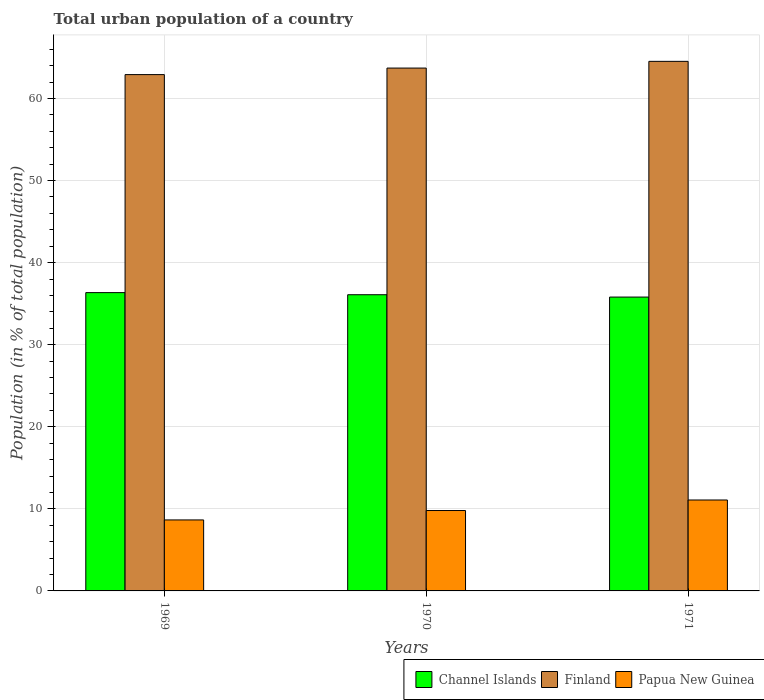What is the label of the 2nd group of bars from the left?
Provide a short and direct response. 1970. In how many cases, is the number of bars for a given year not equal to the number of legend labels?
Keep it short and to the point. 0. What is the urban population in Papua New Guinea in 1971?
Keep it short and to the point. 11.08. Across all years, what is the maximum urban population in Finland?
Keep it short and to the point. 64.52. Across all years, what is the minimum urban population in Finland?
Your answer should be very brief. 62.91. What is the total urban population in Channel Islands in the graph?
Provide a short and direct response. 108.24. What is the difference between the urban population in Channel Islands in 1970 and that in 1971?
Ensure brevity in your answer.  0.28. What is the difference between the urban population in Finland in 1969 and the urban population in Channel Islands in 1970?
Provide a succinct answer. 26.82. What is the average urban population in Finland per year?
Offer a very short reply. 63.71. In the year 1969, what is the difference between the urban population in Finland and urban population in Papua New Guinea?
Provide a short and direct response. 54.26. In how many years, is the urban population in Finland greater than 6 %?
Your response must be concise. 3. What is the ratio of the urban population in Papua New Guinea in 1970 to that in 1971?
Your answer should be very brief. 0.88. What is the difference between the highest and the second highest urban population in Papua New Guinea?
Your answer should be very brief. 1.28. What is the difference between the highest and the lowest urban population in Finland?
Ensure brevity in your answer.  1.61. In how many years, is the urban population in Papua New Guinea greater than the average urban population in Papua New Guinea taken over all years?
Your answer should be very brief. 1. What does the 2nd bar from the left in 1971 represents?
Keep it short and to the point. Finland. Is it the case that in every year, the sum of the urban population in Finland and urban population in Papua New Guinea is greater than the urban population in Channel Islands?
Your answer should be very brief. Yes. How many bars are there?
Your answer should be compact. 9. Are the values on the major ticks of Y-axis written in scientific E-notation?
Make the answer very short. No. Does the graph contain any zero values?
Ensure brevity in your answer.  No. Where does the legend appear in the graph?
Your response must be concise. Bottom right. How many legend labels are there?
Provide a short and direct response. 3. What is the title of the graph?
Offer a very short reply. Total urban population of a country. What is the label or title of the X-axis?
Offer a terse response. Years. What is the label or title of the Y-axis?
Offer a terse response. Population (in % of total population). What is the Population (in % of total population) in Channel Islands in 1969?
Keep it short and to the point. 36.35. What is the Population (in % of total population) in Finland in 1969?
Provide a succinct answer. 62.91. What is the Population (in % of total population) of Papua New Guinea in 1969?
Offer a terse response. 8.65. What is the Population (in % of total population) in Channel Islands in 1970?
Give a very brief answer. 36.09. What is the Population (in % of total population) in Finland in 1970?
Provide a succinct answer. 63.7. What is the Population (in % of total population) of Papua New Guinea in 1970?
Your answer should be very brief. 9.8. What is the Population (in % of total population) of Channel Islands in 1971?
Keep it short and to the point. 35.8. What is the Population (in % of total population) of Finland in 1971?
Offer a very short reply. 64.52. What is the Population (in % of total population) in Papua New Guinea in 1971?
Give a very brief answer. 11.08. Across all years, what is the maximum Population (in % of total population) in Channel Islands?
Ensure brevity in your answer.  36.35. Across all years, what is the maximum Population (in % of total population) in Finland?
Your answer should be very brief. 64.52. Across all years, what is the maximum Population (in % of total population) of Papua New Guinea?
Keep it short and to the point. 11.08. Across all years, what is the minimum Population (in % of total population) in Channel Islands?
Your answer should be very brief. 35.8. Across all years, what is the minimum Population (in % of total population) in Finland?
Your response must be concise. 62.91. Across all years, what is the minimum Population (in % of total population) of Papua New Guinea?
Your answer should be compact. 8.65. What is the total Population (in % of total population) in Channel Islands in the graph?
Provide a short and direct response. 108.24. What is the total Population (in % of total population) of Finland in the graph?
Make the answer very short. 191.13. What is the total Population (in % of total population) of Papua New Guinea in the graph?
Make the answer very short. 29.52. What is the difference between the Population (in % of total population) in Channel Islands in 1969 and that in 1970?
Keep it short and to the point. 0.26. What is the difference between the Population (in % of total population) of Finland in 1969 and that in 1970?
Your response must be concise. -0.8. What is the difference between the Population (in % of total population) of Papua New Guinea in 1969 and that in 1970?
Keep it short and to the point. -1.15. What is the difference between the Population (in % of total population) in Channel Islands in 1969 and that in 1971?
Provide a short and direct response. 0.54. What is the difference between the Population (in % of total population) of Finland in 1969 and that in 1971?
Your response must be concise. -1.61. What is the difference between the Population (in % of total population) in Papua New Guinea in 1969 and that in 1971?
Give a very brief answer. -2.43. What is the difference between the Population (in % of total population) of Channel Islands in 1970 and that in 1971?
Keep it short and to the point. 0.28. What is the difference between the Population (in % of total population) of Finland in 1970 and that in 1971?
Your answer should be very brief. -0.82. What is the difference between the Population (in % of total population) of Papua New Guinea in 1970 and that in 1971?
Offer a very short reply. -1.28. What is the difference between the Population (in % of total population) of Channel Islands in 1969 and the Population (in % of total population) of Finland in 1970?
Make the answer very short. -27.36. What is the difference between the Population (in % of total population) in Channel Islands in 1969 and the Population (in % of total population) in Papua New Guinea in 1970?
Your response must be concise. 26.55. What is the difference between the Population (in % of total population) of Finland in 1969 and the Population (in % of total population) of Papua New Guinea in 1970?
Your response must be concise. 53.11. What is the difference between the Population (in % of total population) of Channel Islands in 1969 and the Population (in % of total population) of Finland in 1971?
Your response must be concise. -28.18. What is the difference between the Population (in % of total population) of Channel Islands in 1969 and the Population (in % of total population) of Papua New Guinea in 1971?
Your response must be concise. 25.27. What is the difference between the Population (in % of total population) in Finland in 1969 and the Population (in % of total population) in Papua New Guinea in 1971?
Your answer should be compact. 51.83. What is the difference between the Population (in % of total population) of Channel Islands in 1970 and the Population (in % of total population) of Finland in 1971?
Your response must be concise. -28.43. What is the difference between the Population (in % of total population) of Channel Islands in 1970 and the Population (in % of total population) of Papua New Guinea in 1971?
Your answer should be very brief. 25.01. What is the difference between the Population (in % of total population) in Finland in 1970 and the Population (in % of total population) in Papua New Guinea in 1971?
Ensure brevity in your answer.  52.63. What is the average Population (in % of total population) of Channel Islands per year?
Give a very brief answer. 36.08. What is the average Population (in % of total population) of Finland per year?
Keep it short and to the point. 63.71. What is the average Population (in % of total population) of Papua New Guinea per year?
Your answer should be compact. 9.84. In the year 1969, what is the difference between the Population (in % of total population) in Channel Islands and Population (in % of total population) in Finland?
Your answer should be compact. -26.56. In the year 1969, what is the difference between the Population (in % of total population) in Channel Islands and Population (in % of total population) in Papua New Guinea?
Your answer should be compact. 27.7. In the year 1969, what is the difference between the Population (in % of total population) in Finland and Population (in % of total population) in Papua New Guinea?
Your answer should be very brief. 54.26. In the year 1970, what is the difference between the Population (in % of total population) of Channel Islands and Population (in % of total population) of Finland?
Offer a terse response. -27.62. In the year 1970, what is the difference between the Population (in % of total population) of Channel Islands and Population (in % of total population) of Papua New Guinea?
Offer a very short reply. 26.29. In the year 1970, what is the difference between the Population (in % of total population) of Finland and Population (in % of total population) of Papua New Guinea?
Your answer should be compact. 53.91. In the year 1971, what is the difference between the Population (in % of total population) of Channel Islands and Population (in % of total population) of Finland?
Keep it short and to the point. -28.72. In the year 1971, what is the difference between the Population (in % of total population) in Channel Islands and Population (in % of total population) in Papua New Guinea?
Offer a terse response. 24.73. In the year 1971, what is the difference between the Population (in % of total population) of Finland and Population (in % of total population) of Papua New Guinea?
Keep it short and to the point. 53.45. What is the ratio of the Population (in % of total population) in Channel Islands in 1969 to that in 1970?
Offer a very short reply. 1.01. What is the ratio of the Population (in % of total population) of Finland in 1969 to that in 1970?
Your answer should be very brief. 0.99. What is the ratio of the Population (in % of total population) in Papua New Guinea in 1969 to that in 1970?
Give a very brief answer. 0.88. What is the ratio of the Population (in % of total population) of Channel Islands in 1969 to that in 1971?
Your answer should be compact. 1.02. What is the ratio of the Population (in % of total population) of Finland in 1969 to that in 1971?
Offer a terse response. 0.97. What is the ratio of the Population (in % of total population) of Papua New Guinea in 1969 to that in 1971?
Ensure brevity in your answer.  0.78. What is the ratio of the Population (in % of total population) of Finland in 1970 to that in 1971?
Keep it short and to the point. 0.99. What is the ratio of the Population (in % of total population) of Papua New Guinea in 1970 to that in 1971?
Your answer should be very brief. 0.88. What is the difference between the highest and the second highest Population (in % of total population) of Channel Islands?
Offer a very short reply. 0.26. What is the difference between the highest and the second highest Population (in % of total population) of Finland?
Your response must be concise. 0.82. What is the difference between the highest and the second highest Population (in % of total population) of Papua New Guinea?
Your answer should be very brief. 1.28. What is the difference between the highest and the lowest Population (in % of total population) of Channel Islands?
Your answer should be very brief. 0.54. What is the difference between the highest and the lowest Population (in % of total population) of Finland?
Your response must be concise. 1.61. What is the difference between the highest and the lowest Population (in % of total population) in Papua New Guinea?
Provide a short and direct response. 2.43. 